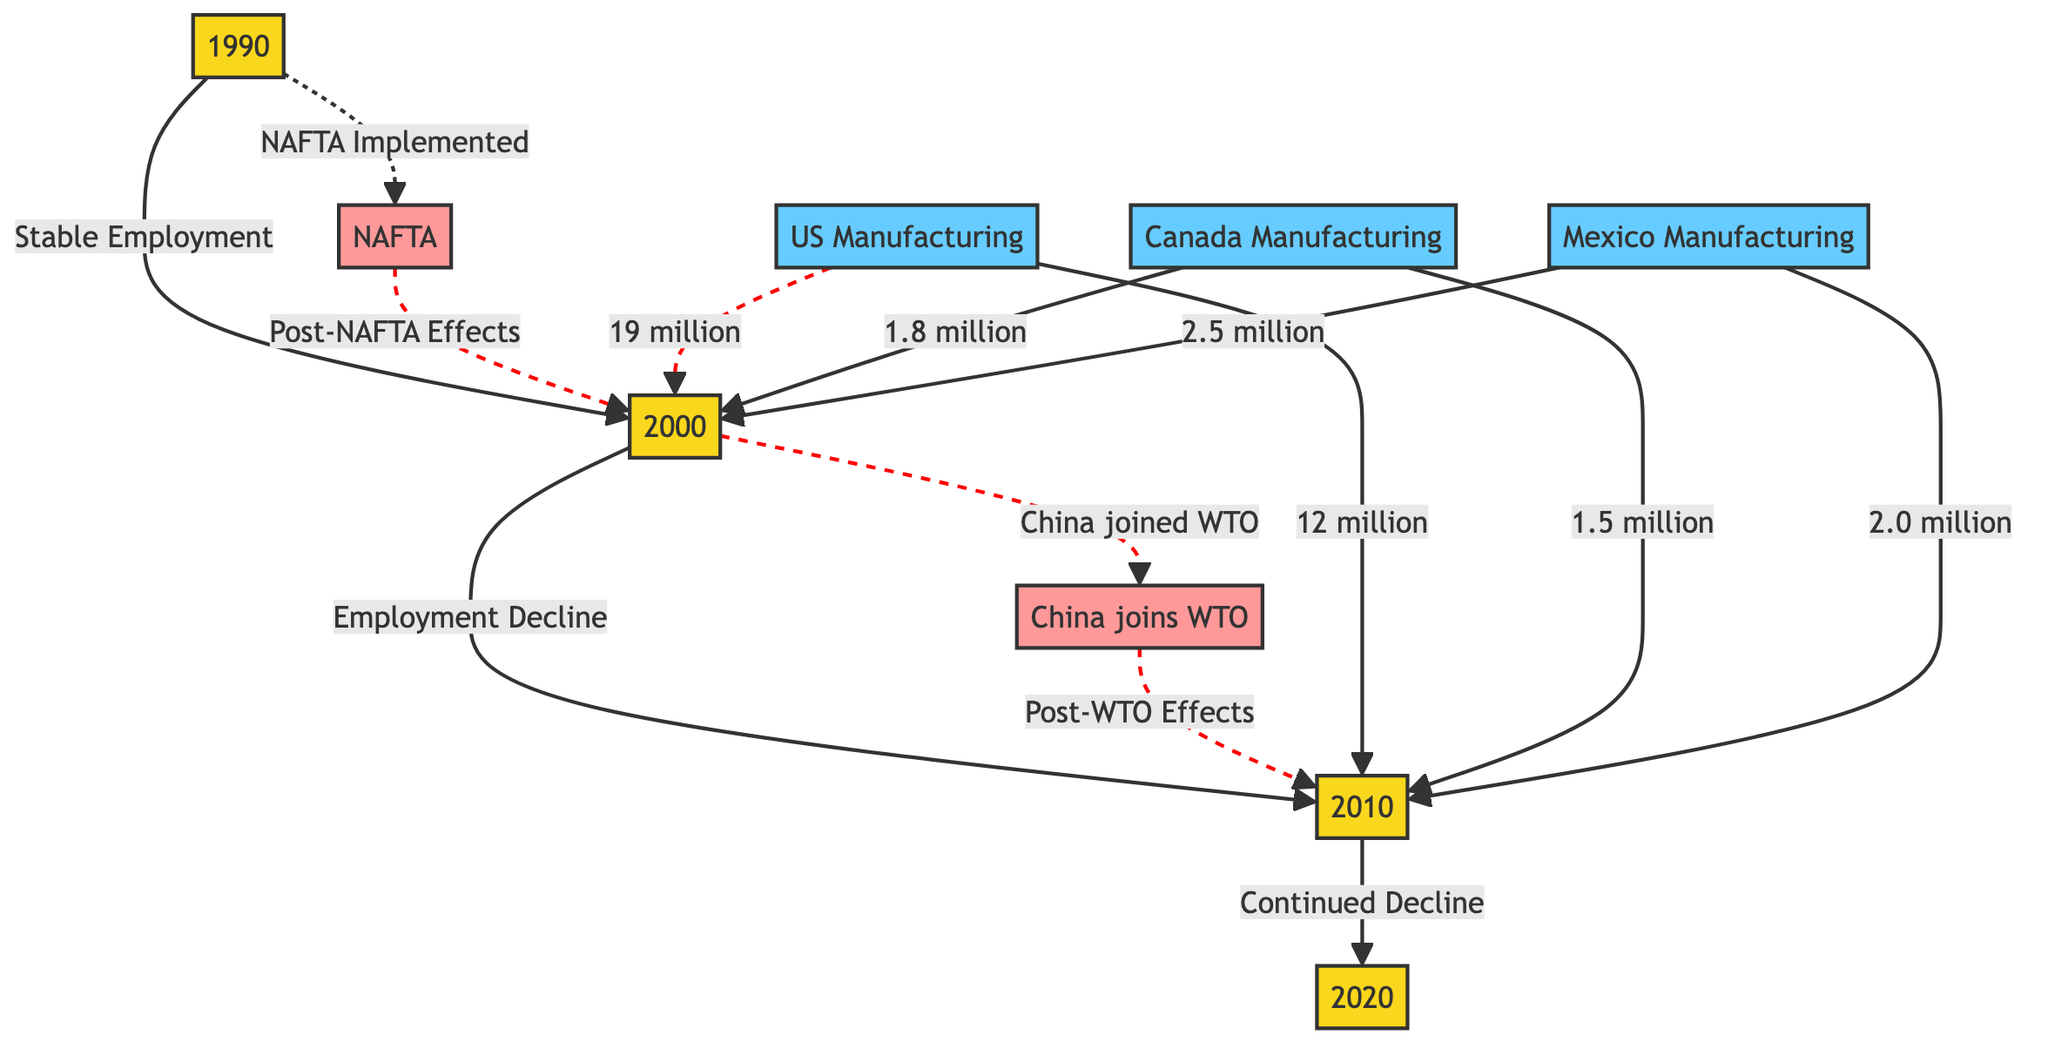What were the employment rates in U.S. manufacturing in 2000? In 2000, U.S. manufacturing employment was noted as 19 million, as indicated in the diagram at the node labeled 'US Manufacturing' pointing to the year 2000.
Answer: 19 million What was the change in employment for Canada manufacturing from 2000 to 2010? For Canada manufacturing, the employment numbers decreased from 1.8 million in 2000 to 1.5 million in 2010, as seen by comparing the respective nodes for each year. The change can be calculated as 1.8 million - 1.5 million.
Answer: 0.3 million What effect did NAFTA have based on the diagram? The diagram shows a dashed line indicating that NAFTA was implemented prior to the change from the stable employment in 1990 to the decline in employment by 2000. This suggests negative effects on employment rates following the implementation.
Answer: Negative effects How many total manufacturing jobs were there in Mexico in 2010 according to the diagram? In 2010, Mexican manufacturing employment was 2.0 million, as represented by the node labeled 'Mexico Manufacturing' pointing to the year 2010.
Answer: 2.0 million What trend is observed in U.S. manufacturing employment from 1990 to 2020? The diagram shows a downward trend in U.S. manufacturing employment, starting from stable employment in 1990, then declining to 19 million in 2000, and further declining to 12 million in 2010, continuing that trend toward 2020.
Answer: Downward trend What significant policy change occurred in 2001? The diagram notes that China joined the WTO after 2000, which is marked as a significant policy change affecting the subsequent employment decline.
Answer: China joined WTO What was the employment rate in Mexican manufacturing in 1990? The diagram does not provide an explicit employment figure for Mexico in 1990, but it indicates that there are changes noted for the subsequent years. Thus, the specific rate for 1990 is not visible in the diagram.
Answer: Not visible How does employment in U.S. manufacturing in 2010 compare to that in 2000? The diagram depicts that employment in U.S. manufacturing decreased from 19 million in 2000 to 12 million in 2010, which highlights a reduction of 7 million jobs.
Answer: Decrease of 7 million What year shows the lowest employment value for Mexican manufacturing? The lowest employment value for Mexican manufacturing shown in the diagram is 2.0 million, reached in 2010.
Answer: 2.0 million 